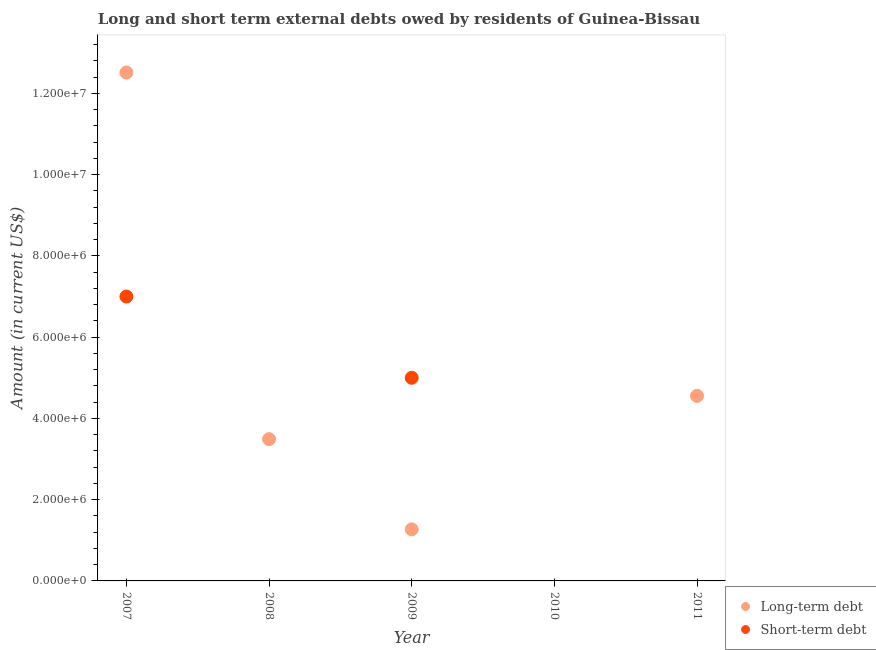How many different coloured dotlines are there?
Offer a very short reply. 2. What is the short-term debts owed by residents in 2010?
Your response must be concise. 0. Across all years, what is the maximum short-term debts owed by residents?
Ensure brevity in your answer.  7.00e+06. In which year was the short-term debts owed by residents maximum?
Make the answer very short. 2007. What is the total short-term debts owed by residents in the graph?
Your answer should be compact. 1.20e+07. What is the difference between the long-term debts owed by residents in 2008 and that in 2009?
Your answer should be compact. 2.22e+06. What is the difference between the short-term debts owed by residents in 2007 and the long-term debts owed by residents in 2009?
Offer a very short reply. 5.73e+06. What is the average short-term debts owed by residents per year?
Your response must be concise. 2.40e+06. In the year 2007, what is the difference between the long-term debts owed by residents and short-term debts owed by residents?
Your answer should be compact. 5.52e+06. In how many years, is the short-term debts owed by residents greater than 6800000 US$?
Keep it short and to the point. 1. What is the ratio of the long-term debts owed by residents in 2009 to that in 2011?
Your answer should be compact. 0.28. Is the short-term debts owed by residents in 2007 less than that in 2009?
Offer a very short reply. No. Is the difference between the long-term debts owed by residents in 2007 and 2009 greater than the difference between the short-term debts owed by residents in 2007 and 2009?
Provide a short and direct response. Yes. What is the difference between the highest and the second highest long-term debts owed by residents?
Provide a succinct answer. 7.96e+06. What is the difference between the highest and the lowest long-term debts owed by residents?
Ensure brevity in your answer.  1.25e+07. In how many years, is the long-term debts owed by residents greater than the average long-term debts owed by residents taken over all years?
Ensure brevity in your answer.  2. Does the long-term debts owed by residents monotonically increase over the years?
Your response must be concise. No. Is the short-term debts owed by residents strictly greater than the long-term debts owed by residents over the years?
Ensure brevity in your answer.  No. Is the long-term debts owed by residents strictly less than the short-term debts owed by residents over the years?
Ensure brevity in your answer.  No. How many dotlines are there?
Give a very brief answer. 2. How are the legend labels stacked?
Your answer should be compact. Vertical. What is the title of the graph?
Offer a terse response. Long and short term external debts owed by residents of Guinea-Bissau. Does "Urban agglomerations" appear as one of the legend labels in the graph?
Keep it short and to the point. No. What is the label or title of the Y-axis?
Your response must be concise. Amount (in current US$). What is the Amount (in current US$) in Long-term debt in 2007?
Provide a short and direct response. 1.25e+07. What is the Amount (in current US$) of Short-term debt in 2007?
Your answer should be compact. 7.00e+06. What is the Amount (in current US$) of Long-term debt in 2008?
Make the answer very short. 3.49e+06. What is the Amount (in current US$) of Short-term debt in 2008?
Provide a succinct answer. 0. What is the Amount (in current US$) in Long-term debt in 2009?
Your answer should be very brief. 1.27e+06. What is the Amount (in current US$) of Short-term debt in 2010?
Your response must be concise. 0. What is the Amount (in current US$) in Long-term debt in 2011?
Provide a succinct answer. 4.56e+06. Across all years, what is the maximum Amount (in current US$) in Long-term debt?
Ensure brevity in your answer.  1.25e+07. Across all years, what is the minimum Amount (in current US$) of Long-term debt?
Keep it short and to the point. 0. What is the total Amount (in current US$) in Long-term debt in the graph?
Give a very brief answer. 2.18e+07. What is the difference between the Amount (in current US$) in Long-term debt in 2007 and that in 2008?
Keep it short and to the point. 9.02e+06. What is the difference between the Amount (in current US$) in Long-term debt in 2007 and that in 2009?
Provide a succinct answer. 1.12e+07. What is the difference between the Amount (in current US$) of Long-term debt in 2007 and that in 2011?
Make the answer very short. 7.96e+06. What is the difference between the Amount (in current US$) of Long-term debt in 2008 and that in 2009?
Your answer should be very brief. 2.22e+06. What is the difference between the Amount (in current US$) of Long-term debt in 2008 and that in 2011?
Make the answer very short. -1.06e+06. What is the difference between the Amount (in current US$) of Long-term debt in 2009 and that in 2011?
Ensure brevity in your answer.  -3.29e+06. What is the difference between the Amount (in current US$) in Long-term debt in 2007 and the Amount (in current US$) in Short-term debt in 2009?
Make the answer very short. 7.52e+06. What is the difference between the Amount (in current US$) in Long-term debt in 2008 and the Amount (in current US$) in Short-term debt in 2009?
Offer a terse response. -1.51e+06. What is the average Amount (in current US$) of Long-term debt per year?
Offer a very short reply. 4.37e+06. What is the average Amount (in current US$) in Short-term debt per year?
Provide a short and direct response. 2.40e+06. In the year 2007, what is the difference between the Amount (in current US$) in Long-term debt and Amount (in current US$) in Short-term debt?
Your answer should be compact. 5.52e+06. In the year 2009, what is the difference between the Amount (in current US$) of Long-term debt and Amount (in current US$) of Short-term debt?
Keep it short and to the point. -3.73e+06. What is the ratio of the Amount (in current US$) of Long-term debt in 2007 to that in 2008?
Offer a terse response. 3.59. What is the ratio of the Amount (in current US$) in Long-term debt in 2007 to that in 2009?
Offer a terse response. 9.86. What is the ratio of the Amount (in current US$) in Short-term debt in 2007 to that in 2009?
Offer a very short reply. 1.4. What is the ratio of the Amount (in current US$) of Long-term debt in 2007 to that in 2011?
Make the answer very short. 2.75. What is the ratio of the Amount (in current US$) of Long-term debt in 2008 to that in 2009?
Make the answer very short. 2.75. What is the ratio of the Amount (in current US$) of Long-term debt in 2008 to that in 2011?
Make the answer very short. 0.77. What is the ratio of the Amount (in current US$) in Long-term debt in 2009 to that in 2011?
Your answer should be compact. 0.28. What is the difference between the highest and the second highest Amount (in current US$) in Long-term debt?
Provide a succinct answer. 7.96e+06. What is the difference between the highest and the lowest Amount (in current US$) of Long-term debt?
Offer a terse response. 1.25e+07. What is the difference between the highest and the lowest Amount (in current US$) in Short-term debt?
Provide a short and direct response. 7.00e+06. 